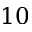Convert formula to latex. <formula><loc_0><loc_0><loc_500><loc_500>1 0</formula> 